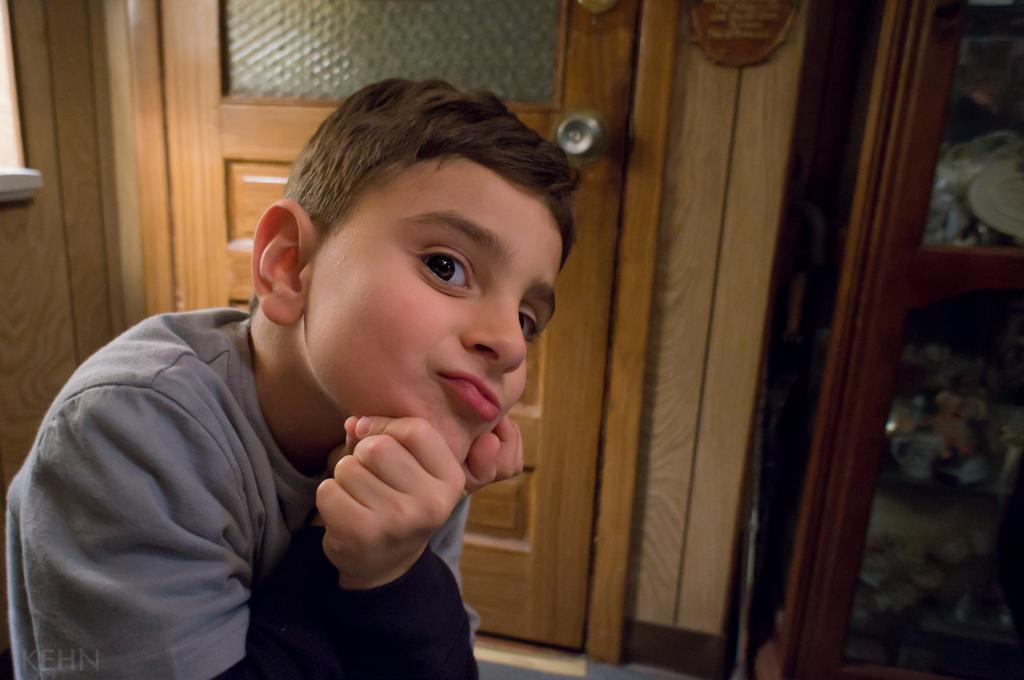Who is the main subject in the image? There is a boy in the image. What is the boy wearing? The boy is wearing a gray t-shirt. What is the boy's facial expression? The boy is smiling. What can be seen in the background of the image? There is a wooden door and a cupboard in the background of the image. How many friends are standing next to the boy in the image? There is no mention of friends in the image; only the boy is present. What type of glove is the boy wearing in the image? There is no glove visible in the image; the boy is wearing a gray t-shirt. 